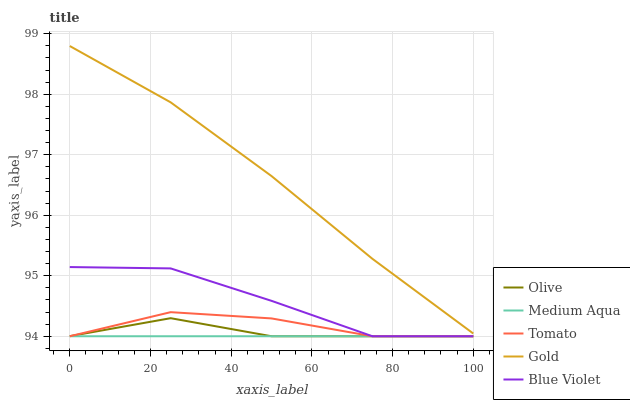Does Medium Aqua have the minimum area under the curve?
Answer yes or no. Yes. Does Gold have the maximum area under the curve?
Answer yes or no. Yes. Does Tomato have the minimum area under the curve?
Answer yes or no. No. Does Tomato have the maximum area under the curve?
Answer yes or no. No. Is Medium Aqua the smoothest?
Answer yes or no. Yes. Is Blue Violet the roughest?
Answer yes or no. Yes. Is Tomato the smoothest?
Answer yes or no. No. Is Tomato the roughest?
Answer yes or no. No. Does Olive have the lowest value?
Answer yes or no. Yes. Does Gold have the lowest value?
Answer yes or no. No. Does Gold have the highest value?
Answer yes or no. Yes. Does Tomato have the highest value?
Answer yes or no. No. Is Olive less than Gold?
Answer yes or no. Yes. Is Gold greater than Blue Violet?
Answer yes or no. Yes. Does Blue Violet intersect Medium Aqua?
Answer yes or no. Yes. Is Blue Violet less than Medium Aqua?
Answer yes or no. No. Is Blue Violet greater than Medium Aqua?
Answer yes or no. No. Does Olive intersect Gold?
Answer yes or no. No. 